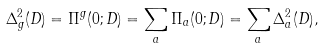<formula> <loc_0><loc_0><loc_500><loc_500>\Delta ^ { 2 } _ { g } ( D ) = \Pi ^ { g } ( 0 ; D ) = \sum _ { a } \Pi _ { a } ( 0 ; D ) = \sum _ { a } \Delta ^ { 2 } _ { a } ( D ) ,</formula> 